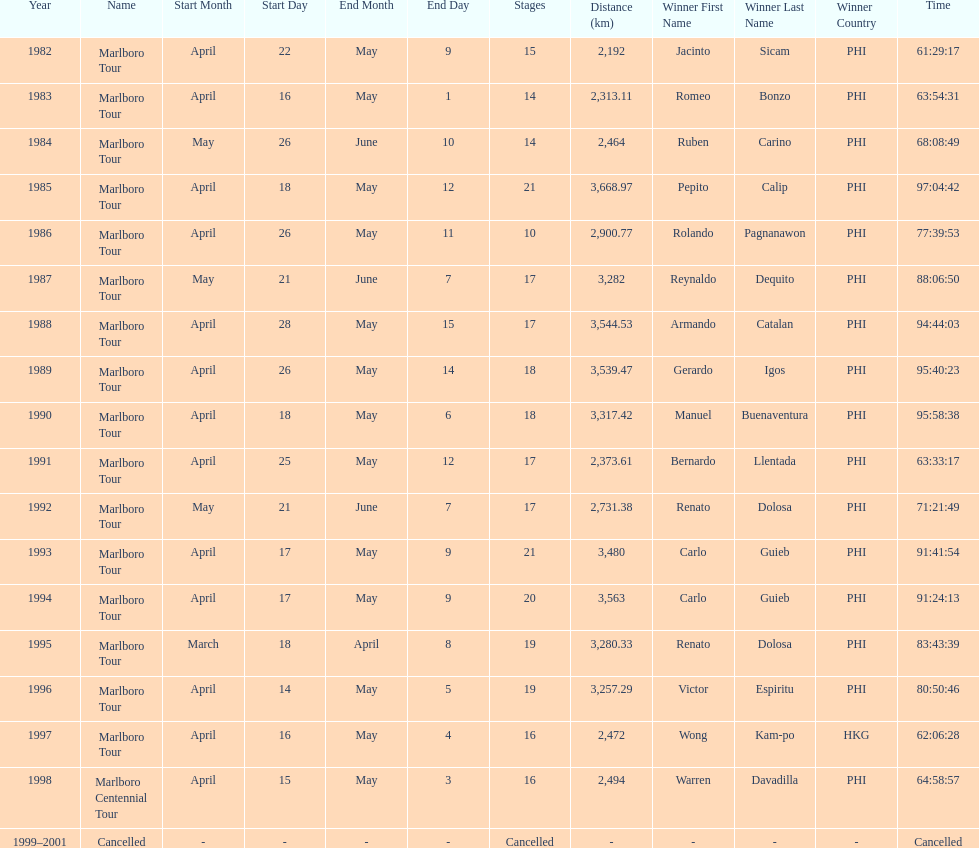How many marlboro tours did carlo guieb win? 2. 